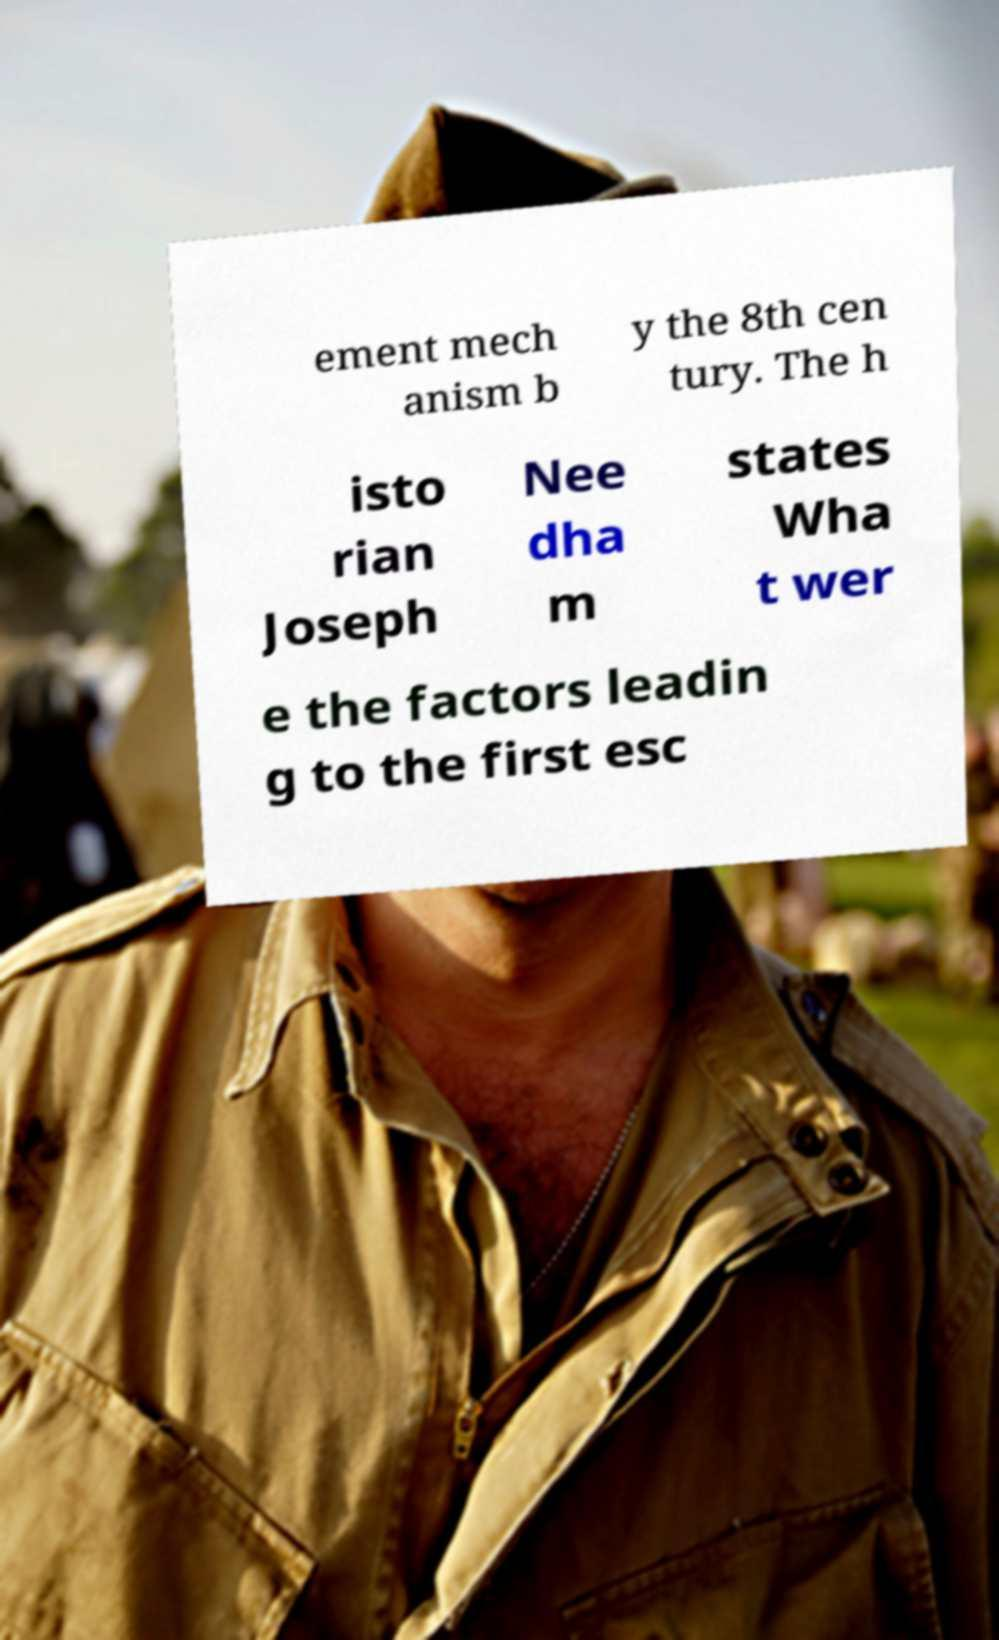I need the written content from this picture converted into text. Can you do that? ement mech anism b y the 8th cen tury. The h isto rian Joseph Nee dha m states Wha t wer e the factors leadin g to the first esc 